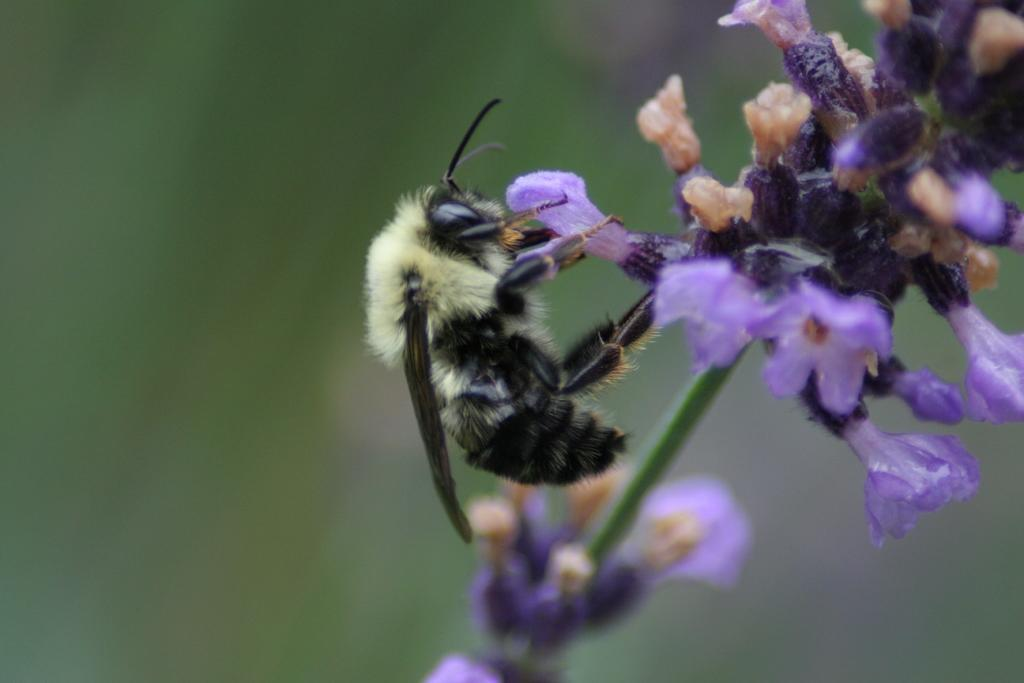What is the main subject of the image? The main subject of the image is a bee. What is the bee doing in the image? The bee is eating a flower in the image. Can you describe the background of the image? The background of the image is blurred. What type of wood is the bee using to build its nest in the image? There is no wood or nest visible in the image; it features a bee eating a flower. How many passengers can be seen traveling with the bee in the image? There are no passengers present in the image, as it features a bee eating a flower. 